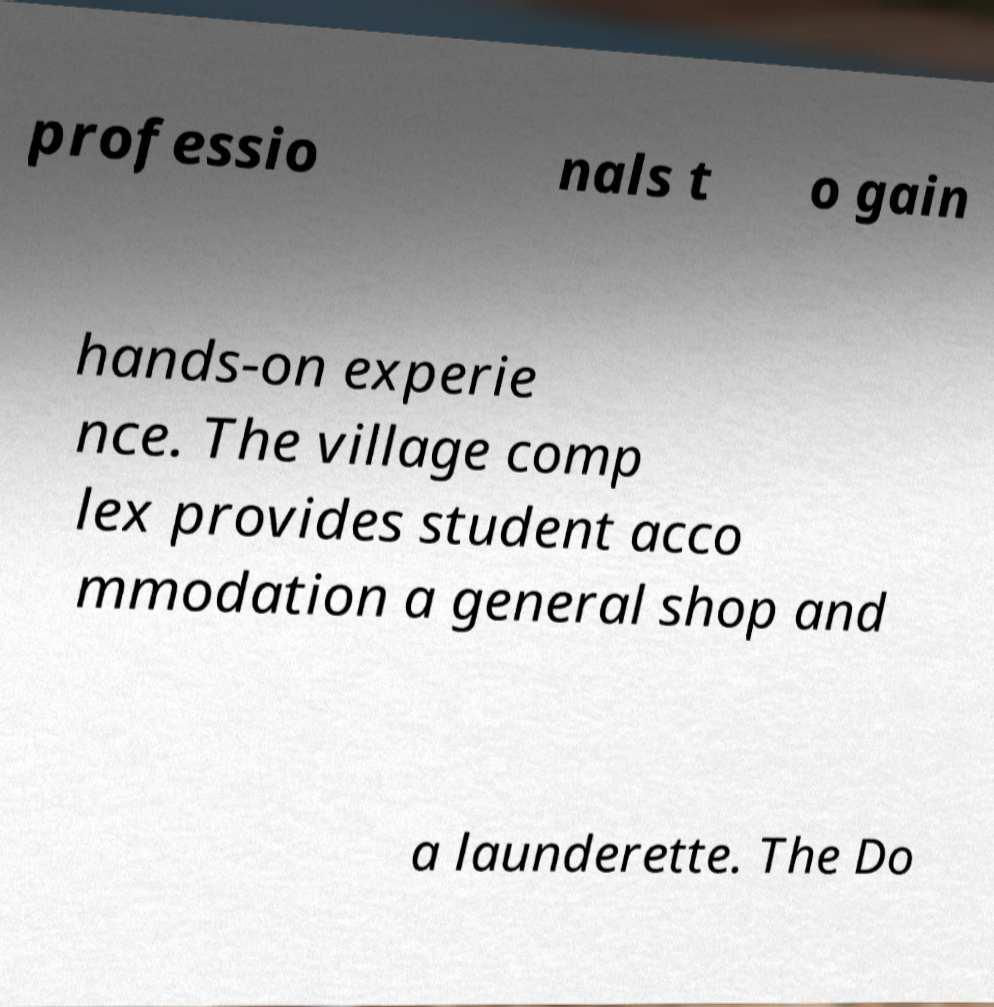Can you read and provide the text displayed in the image?This photo seems to have some interesting text. Can you extract and type it out for me? professio nals t o gain hands-on experie nce. The village comp lex provides student acco mmodation a general shop and a launderette. The Do 